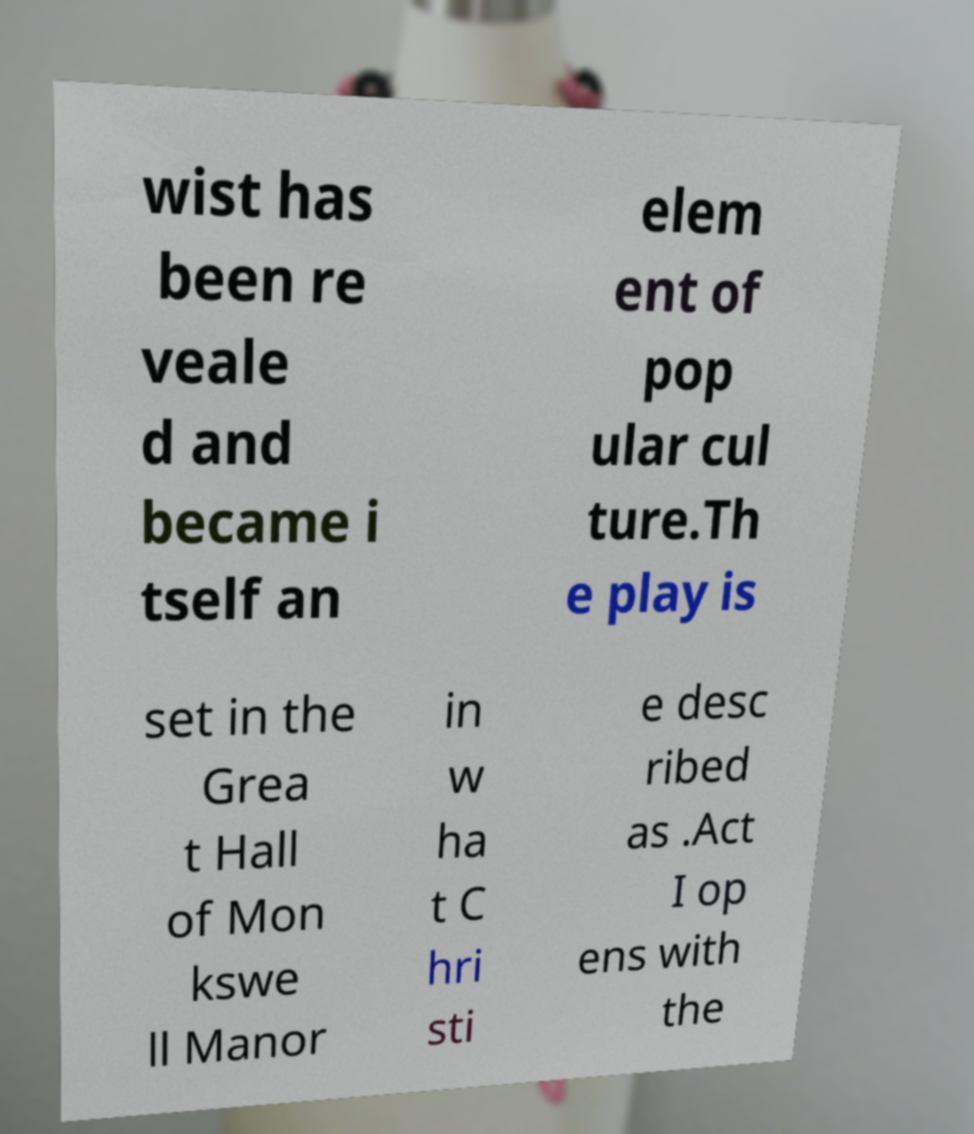For documentation purposes, I need the text within this image transcribed. Could you provide that? wist has been re veale d and became i tself an elem ent of pop ular cul ture.Th e play is set in the Grea t Hall of Mon kswe ll Manor in w ha t C hri sti e desc ribed as .Act I op ens with the 